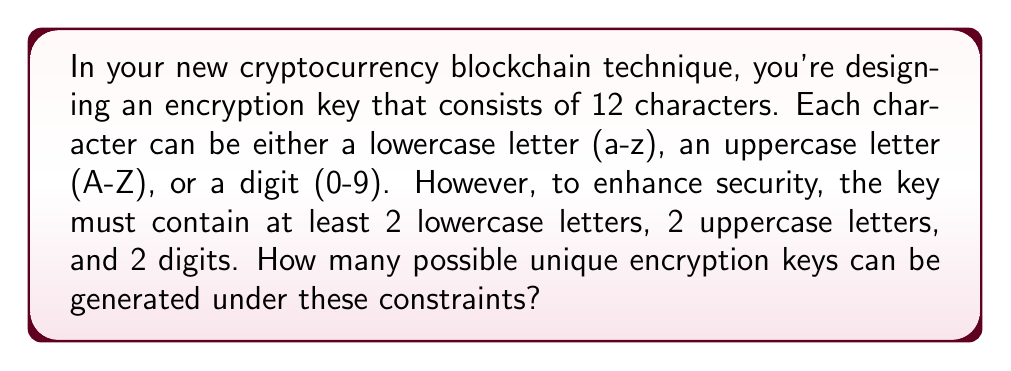Can you solve this math problem? Let's approach this step-by-step using the concept of combinations and the inclusion-exclusion principle:

1) First, let's calculate the total number of characters available:
   26 lowercase letters + 26 uppercase letters + 10 digits = 62 total characters

2) We need to ensure at least 2 of each type. Let's start by selecting these:
   $\binom{26}{2}$ ways to choose 2 lowercase letters
   $\binom{26}{2}$ ways to choose 2 uppercase letters
   $\binom{10}{2}$ ways to choose 2 digits

3) Now we have 6 positions filled, and 6 remaining. For these 6, we can use any of the 62 characters.

4) However, this approach will overcount some cases. We need to subtract the cases where we don't have at least 2 of each type in the remaining 6 positions.

5) Let's use the inclusion-exclusion principle. Define:
   A: less than 2 lowercase in remaining 6
   B: less than 2 uppercase in remaining 6
   C: less than 2 digits in remaining 6

6) We need to calculate: Total - (A + B + C - AB - AC - BC + ABC)

   Where:
   A = $\binom{26}{1} \cdot 36^6 + 36^6$
   B = $\binom{26}{1} \cdot 36^6 + 36^6$
   C = $\binom{10}{1} \cdot 52^6 + 52^6$
   AB = $\binom{26}{1} \cdot \binom{26}{1} \cdot 10^6 + \binom{26}{1} \cdot 10^6 + \binom{26}{1} \cdot 10^6 + 10^6$
   AC = $\binom{26}{1} \cdot \binom{10}{1} \cdot 26^6 + \binom{26}{1} \cdot 26^6 + \binom{10}{1} \cdot 26^6 + 26^6$
   BC = $\binom{26}{1} \cdot \binom{10}{1} \cdot 26^6 + \binom{26}{1} \cdot 26^6 + \binom{10}{1} \cdot 26^6 + 26^6$
   ABC = $0$ (as we can't have less than 2 of all types in 6 positions)

7) Putting it all together:

   $$\binom{26}{2} \cdot \binom{26}{2} \cdot \binom{10}{2} \cdot (62^6 - (A + B + C - AB - AC - BC + ABC))$$

8) Calculating this gives us the final result.
Answer: $$3,009,780,720,878,769,352,704,000$$ 